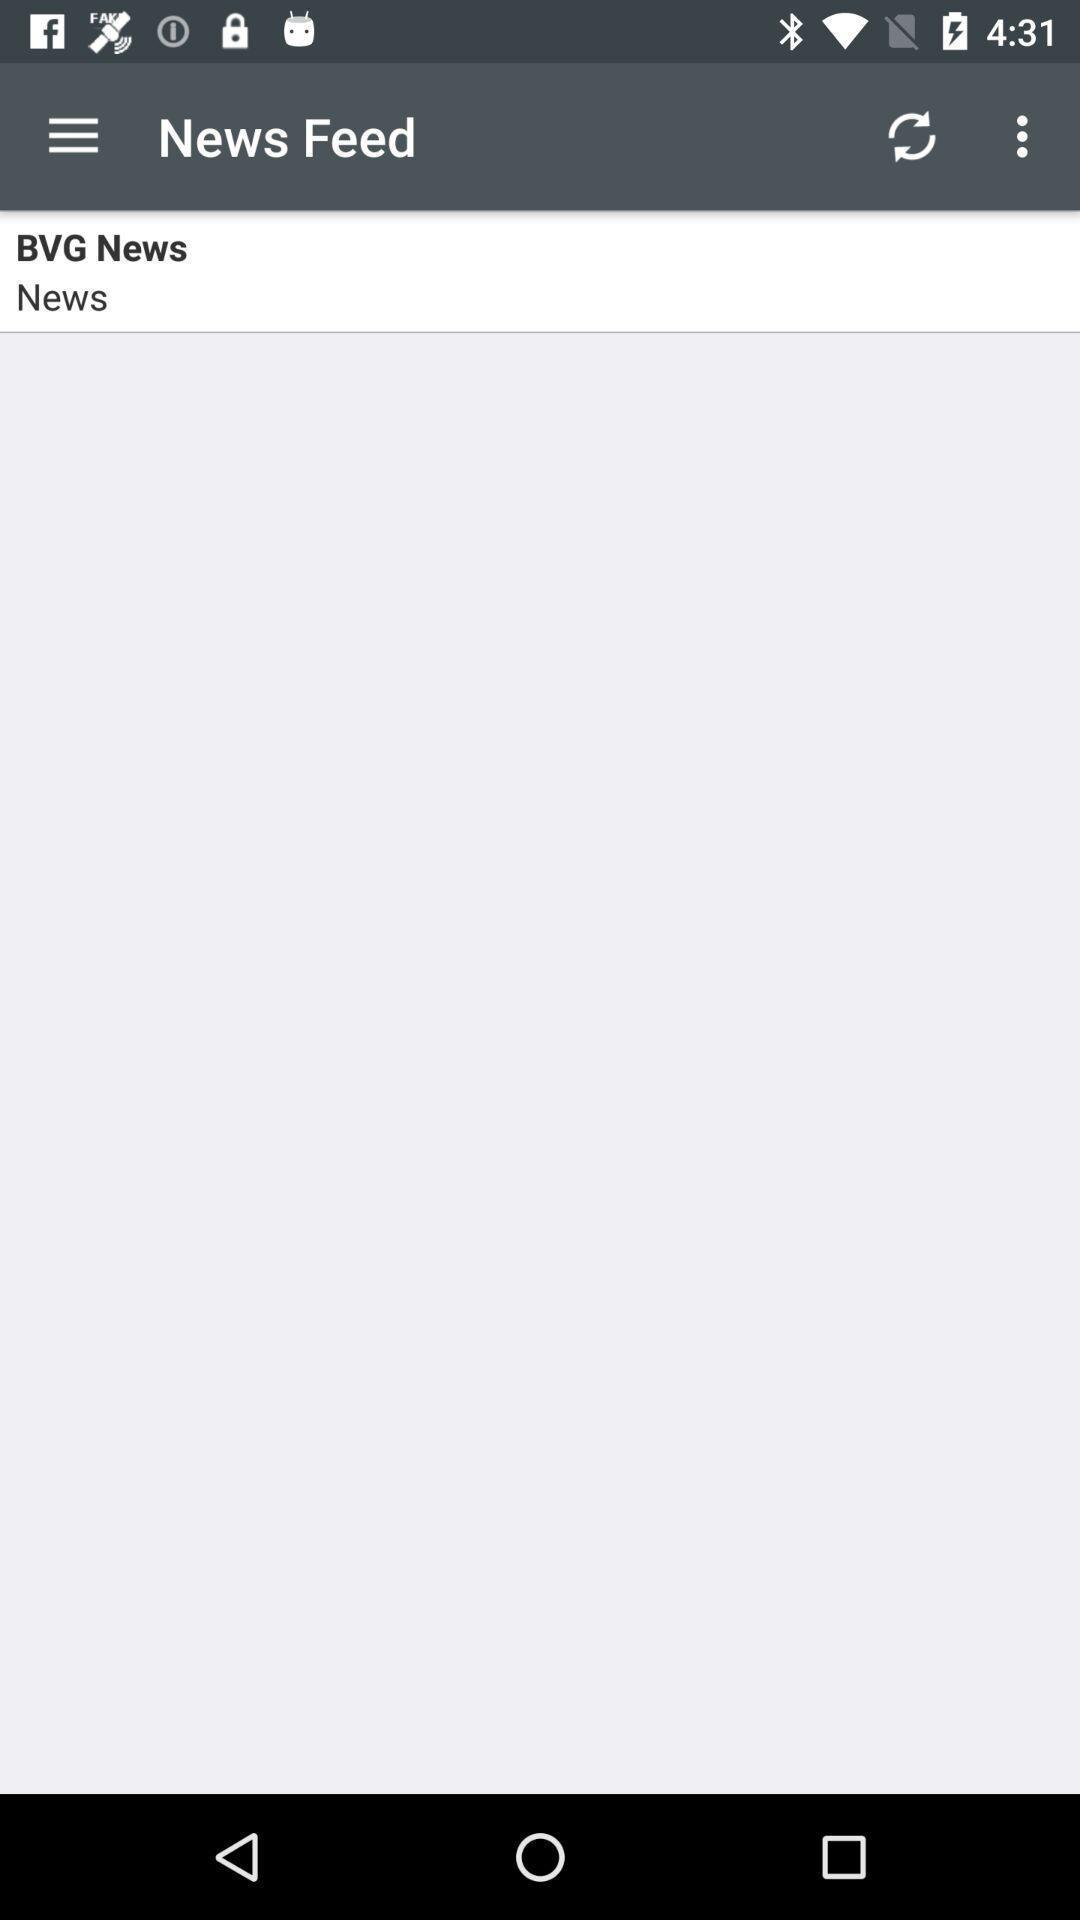Describe the content in this image. Page shows the news feed option on news app. 